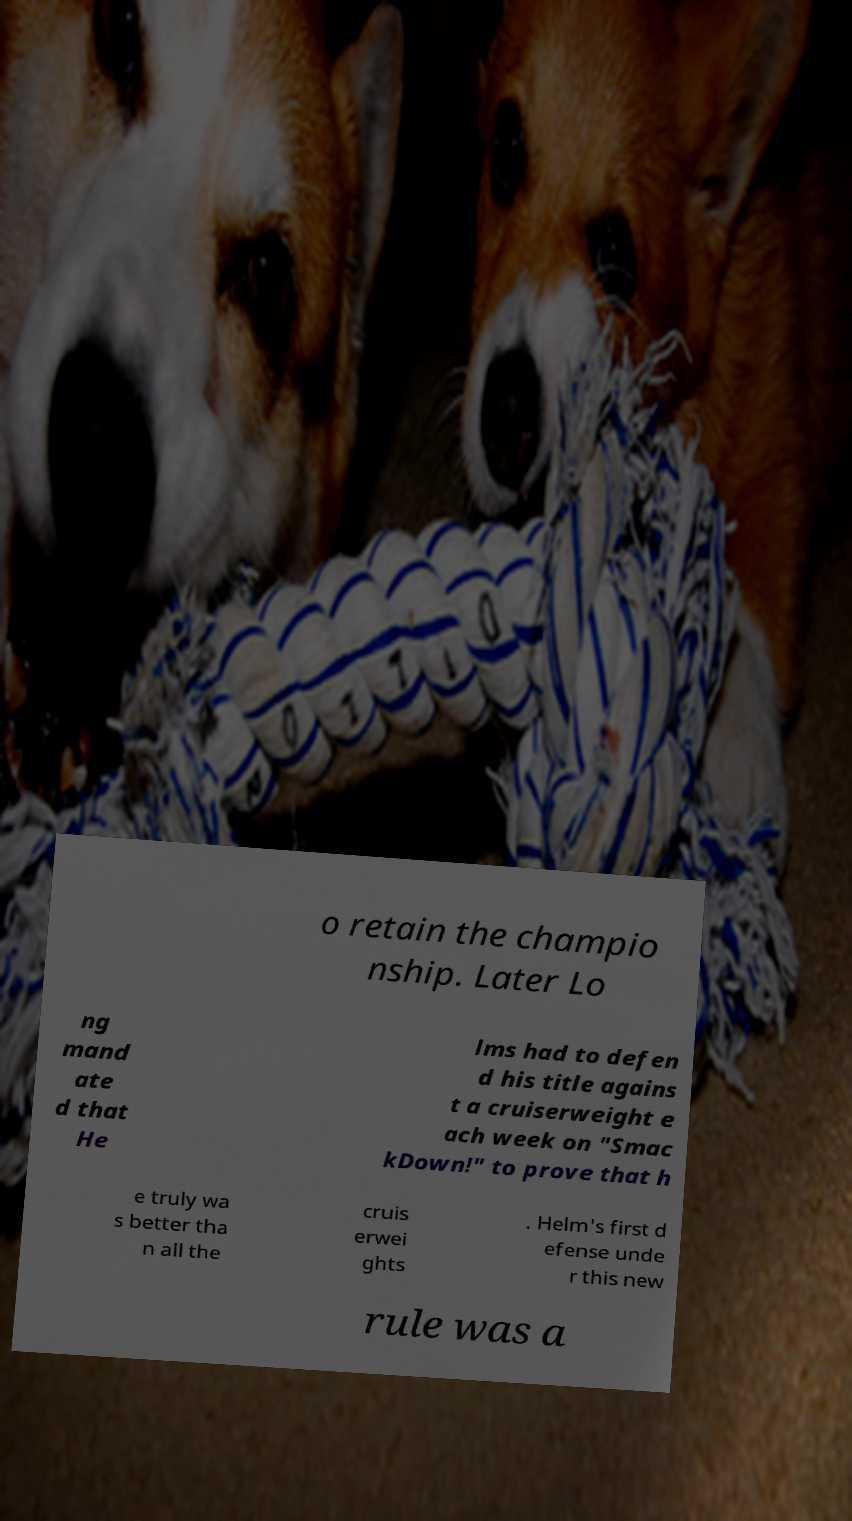Could you assist in decoding the text presented in this image and type it out clearly? o retain the champio nship. Later Lo ng mand ate d that He lms had to defen d his title agains t a cruiserweight e ach week on "Smac kDown!" to prove that h e truly wa s better tha n all the cruis erwei ghts . Helm's first d efense unde r this new rule was a 